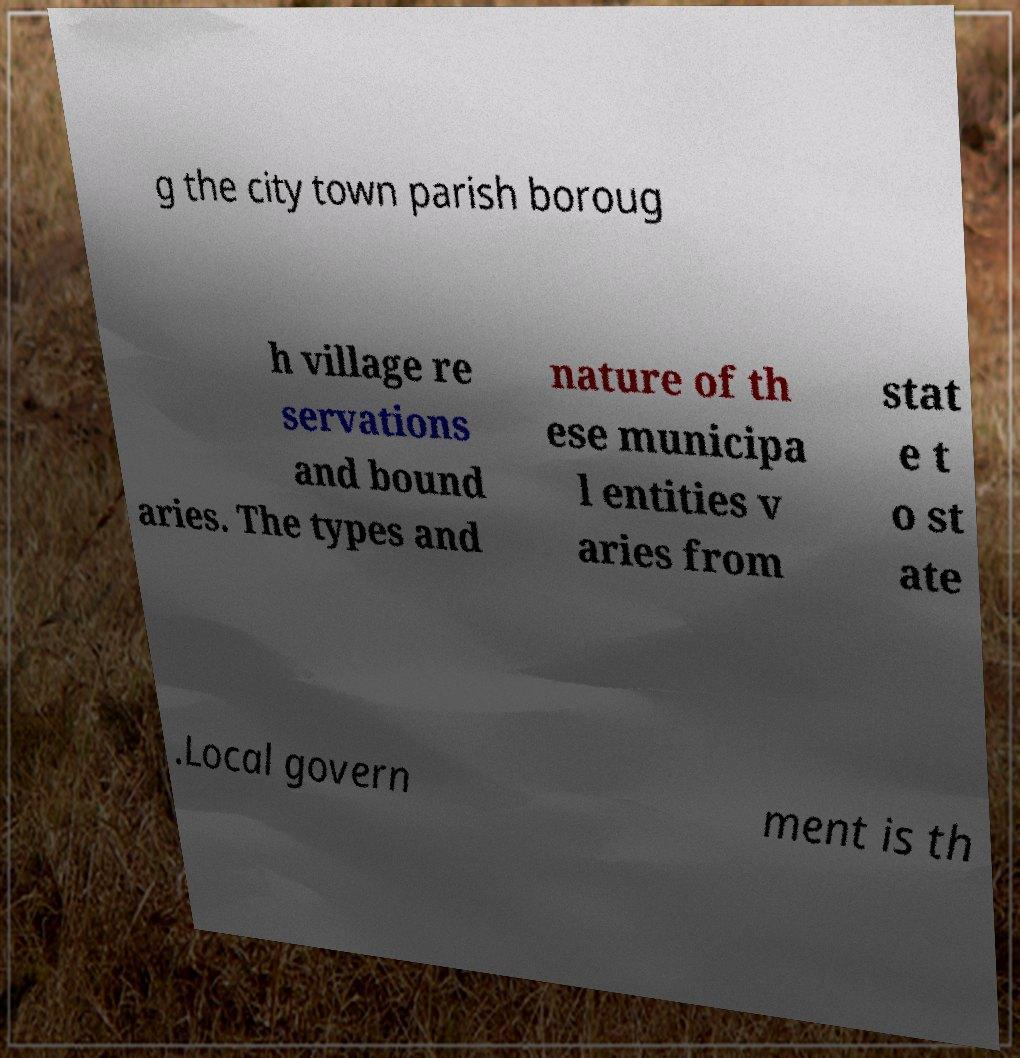Could you extract and type out the text from this image? g the city town parish boroug h village re servations and bound aries. The types and nature of th ese municipa l entities v aries from stat e t o st ate .Local govern ment is th 